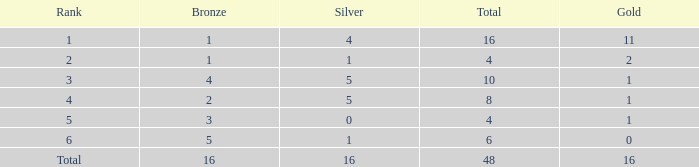How many total gold are less than 4? 0.0. 